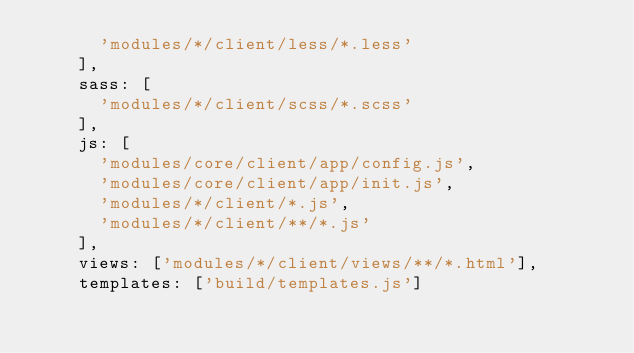Convert code to text. <code><loc_0><loc_0><loc_500><loc_500><_JavaScript_>      'modules/*/client/less/*.less'
    ],
    sass: [
      'modules/*/client/scss/*.scss'
    ],
    js: [
      'modules/core/client/app/config.js',
      'modules/core/client/app/init.js',
      'modules/*/client/*.js',
      'modules/*/client/**/*.js'
    ],
    views: ['modules/*/client/views/**/*.html'],
    templates: ['build/templates.js']</code> 